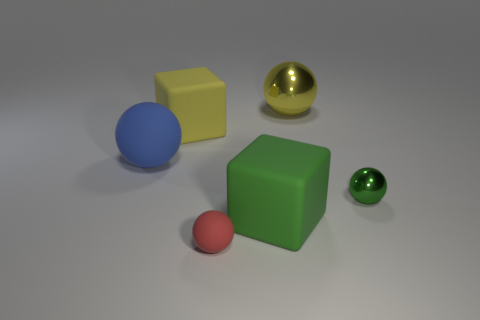Are there any objects that reflect light in a way that suggests they are made of metal? Yes, the golden sphere has a reflective surface that is indicative of a metallic material.  Compared to the other objects, how would you describe the surface texture of the red object? The red object has a matte surface texture, which is different from the shiny, reflective texture of the green sphere and the glossy metallic sheen of the gold sphere. 